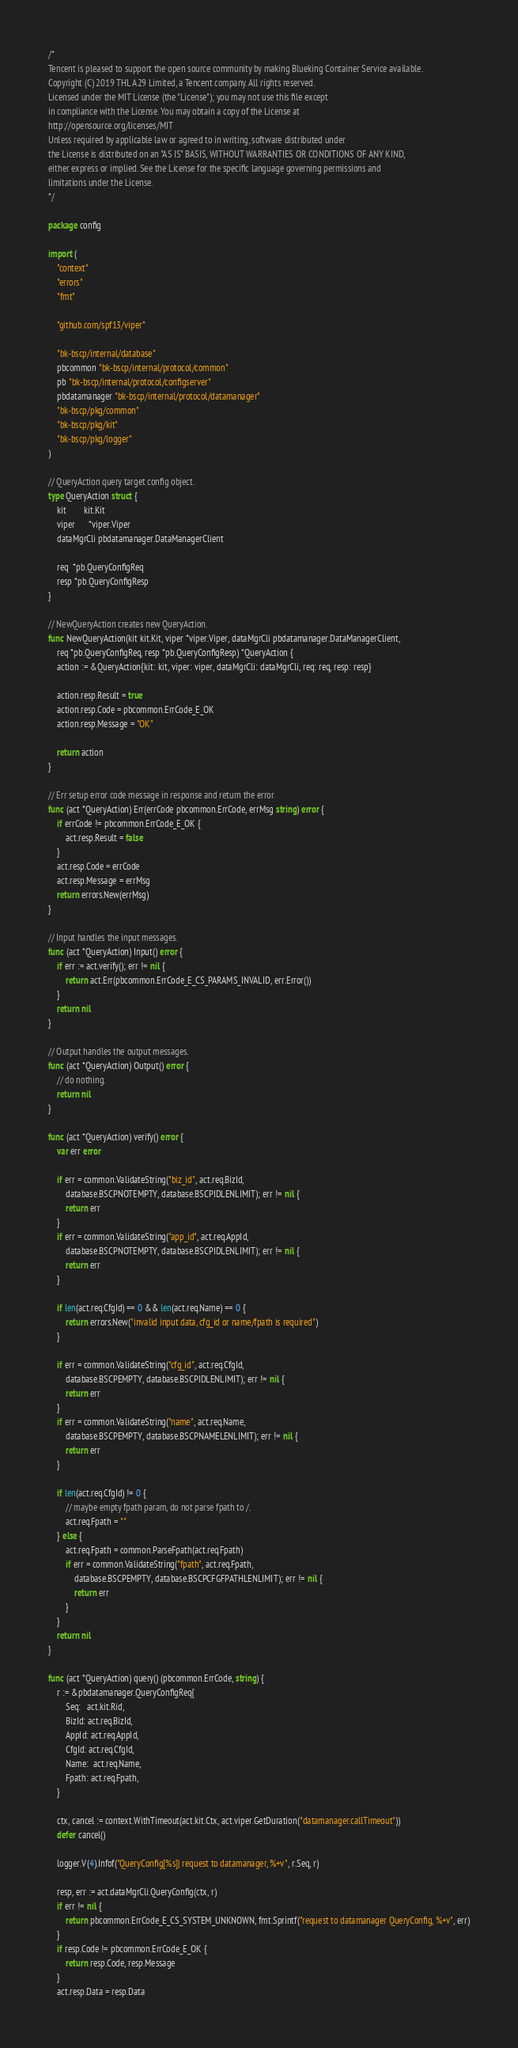Convert code to text. <code><loc_0><loc_0><loc_500><loc_500><_Go_>/*
Tencent is pleased to support the open source community by making Blueking Container Service available.
Copyright (C) 2019 THL A29 Limited, a Tencent company. All rights reserved.
Licensed under the MIT License (the "License"); you may not use this file except
in compliance with the License. You may obtain a copy of the License at
http://opensource.org/licenses/MIT
Unless required by applicable law or agreed to in writing, software distributed under
the License is distributed on an "AS IS" BASIS, WITHOUT WARRANTIES OR CONDITIONS OF ANY KIND,
either express or implied. See the License for the specific language governing permissions and
limitations under the License.
*/

package config

import (
	"context"
	"errors"
	"fmt"

	"github.com/spf13/viper"

	"bk-bscp/internal/database"
	pbcommon "bk-bscp/internal/protocol/common"
	pb "bk-bscp/internal/protocol/configserver"
	pbdatamanager "bk-bscp/internal/protocol/datamanager"
	"bk-bscp/pkg/common"
	"bk-bscp/pkg/kit"
	"bk-bscp/pkg/logger"
)

// QueryAction query target config object.
type QueryAction struct {
	kit        kit.Kit
	viper      *viper.Viper
	dataMgrCli pbdatamanager.DataManagerClient

	req  *pb.QueryConfigReq
	resp *pb.QueryConfigResp
}

// NewQueryAction creates new QueryAction.
func NewQueryAction(kit kit.Kit, viper *viper.Viper, dataMgrCli pbdatamanager.DataManagerClient,
	req *pb.QueryConfigReq, resp *pb.QueryConfigResp) *QueryAction {
	action := &QueryAction{kit: kit, viper: viper, dataMgrCli: dataMgrCli, req: req, resp: resp}

	action.resp.Result = true
	action.resp.Code = pbcommon.ErrCode_E_OK
	action.resp.Message = "OK"

	return action
}

// Err setup error code message in response and return the error.
func (act *QueryAction) Err(errCode pbcommon.ErrCode, errMsg string) error {
	if errCode != pbcommon.ErrCode_E_OK {
		act.resp.Result = false
	}
	act.resp.Code = errCode
	act.resp.Message = errMsg
	return errors.New(errMsg)
}

// Input handles the input messages.
func (act *QueryAction) Input() error {
	if err := act.verify(); err != nil {
		return act.Err(pbcommon.ErrCode_E_CS_PARAMS_INVALID, err.Error())
	}
	return nil
}

// Output handles the output messages.
func (act *QueryAction) Output() error {
	// do nothing.
	return nil
}

func (act *QueryAction) verify() error {
	var err error

	if err = common.ValidateString("biz_id", act.req.BizId,
		database.BSCPNOTEMPTY, database.BSCPIDLENLIMIT); err != nil {
		return err
	}
	if err = common.ValidateString("app_id", act.req.AppId,
		database.BSCPNOTEMPTY, database.BSCPIDLENLIMIT); err != nil {
		return err
	}

	if len(act.req.CfgId) == 0 && len(act.req.Name) == 0 {
		return errors.New("invalid input data, cfg_id or name/fpath is required")
	}

	if err = common.ValidateString("cfg_id", act.req.CfgId,
		database.BSCPEMPTY, database.BSCPIDLENLIMIT); err != nil {
		return err
	}
	if err = common.ValidateString("name", act.req.Name,
		database.BSCPEMPTY, database.BSCPNAMELENLIMIT); err != nil {
		return err
	}

	if len(act.req.CfgId) != 0 {
		// maybe empty fpath param, do not parse fpath to /.
		act.req.Fpath = ""
	} else {
		act.req.Fpath = common.ParseFpath(act.req.Fpath)
		if err = common.ValidateString("fpath", act.req.Fpath,
			database.BSCPEMPTY, database.BSCPCFGFPATHLENLIMIT); err != nil {
			return err
		}
	}
	return nil
}

func (act *QueryAction) query() (pbcommon.ErrCode, string) {
	r := &pbdatamanager.QueryConfigReq{
		Seq:   act.kit.Rid,
		BizId: act.req.BizId,
		AppId: act.req.AppId,
		CfgId: act.req.CfgId,
		Name:  act.req.Name,
		Fpath: act.req.Fpath,
	}

	ctx, cancel := context.WithTimeout(act.kit.Ctx, act.viper.GetDuration("datamanager.callTimeout"))
	defer cancel()

	logger.V(4).Infof("QueryConfig[%s]| request to datamanager, %+v", r.Seq, r)

	resp, err := act.dataMgrCli.QueryConfig(ctx, r)
	if err != nil {
		return pbcommon.ErrCode_E_CS_SYSTEM_UNKNOWN, fmt.Sprintf("request to datamanager QueryConfig, %+v", err)
	}
	if resp.Code != pbcommon.ErrCode_E_OK {
		return resp.Code, resp.Message
	}
	act.resp.Data = resp.Data
</code> 